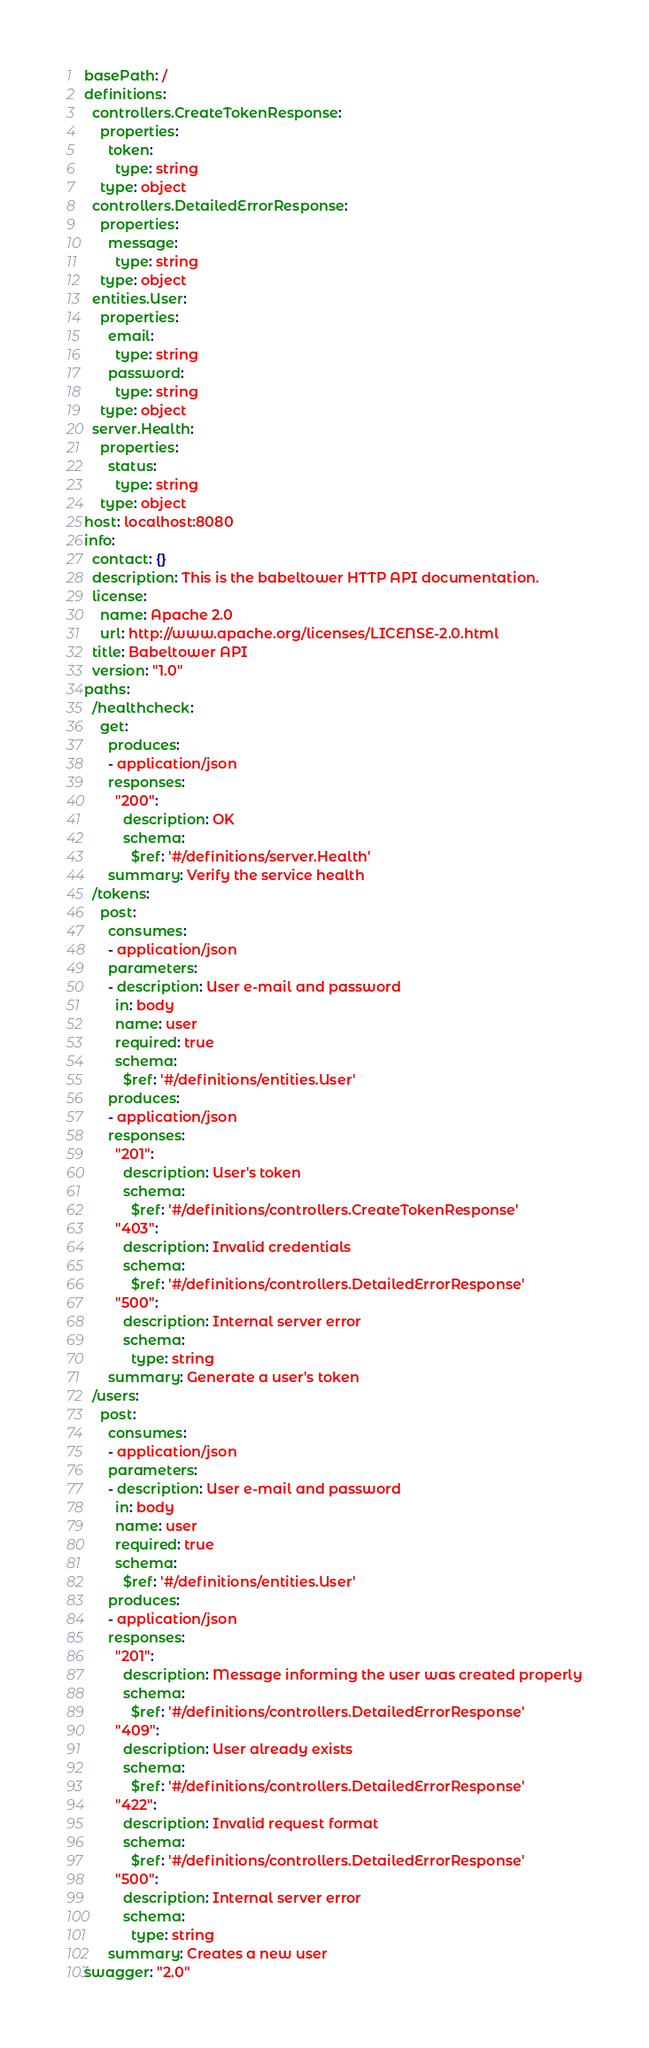<code> <loc_0><loc_0><loc_500><loc_500><_YAML_>basePath: /
definitions:
  controllers.CreateTokenResponse:
    properties:
      token:
        type: string
    type: object
  controllers.DetailedErrorResponse:
    properties:
      message:
        type: string
    type: object
  entities.User:
    properties:
      email:
        type: string
      password:
        type: string
    type: object
  server.Health:
    properties:
      status:
        type: string
    type: object
host: localhost:8080
info:
  contact: {}
  description: This is the babeltower HTTP API documentation.
  license:
    name: Apache 2.0
    url: http://www.apache.org/licenses/LICENSE-2.0.html
  title: Babeltower API
  version: "1.0"
paths:
  /healthcheck:
    get:
      produces:
      - application/json
      responses:
        "200":
          description: OK
          schema:
            $ref: '#/definitions/server.Health'
      summary: Verify the service health
  /tokens:
    post:
      consumes:
      - application/json
      parameters:
      - description: User e-mail and password
        in: body
        name: user
        required: true
        schema:
          $ref: '#/definitions/entities.User'
      produces:
      - application/json
      responses:
        "201":
          description: User's token
          schema:
            $ref: '#/definitions/controllers.CreateTokenResponse'
        "403":
          description: Invalid credentials
          schema:
            $ref: '#/definitions/controllers.DetailedErrorResponse'
        "500":
          description: Internal server error
          schema:
            type: string
      summary: Generate a user's token
  /users:
    post:
      consumes:
      - application/json
      parameters:
      - description: User e-mail and password
        in: body
        name: user
        required: true
        schema:
          $ref: '#/definitions/entities.User'
      produces:
      - application/json
      responses:
        "201":
          description: Message informing the user was created properly
          schema:
            $ref: '#/definitions/controllers.DetailedErrorResponse'
        "409":
          description: User already exists
          schema:
            $ref: '#/definitions/controllers.DetailedErrorResponse'
        "422":
          description: Invalid request format
          schema:
            $ref: '#/definitions/controllers.DetailedErrorResponse'
        "500":
          description: Internal server error
          schema:
            type: string
      summary: Creates a new user
swagger: "2.0"
</code> 